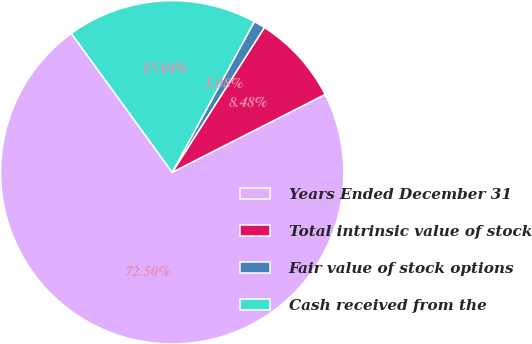Convert chart. <chart><loc_0><loc_0><loc_500><loc_500><pie_chart><fcel>Years Ended December 31<fcel>Total intrinsic value of stock<fcel>Fair value of stock options<fcel>Cash received from the<nl><fcel>72.5%<fcel>8.48%<fcel>1.08%<fcel>17.94%<nl></chart> 